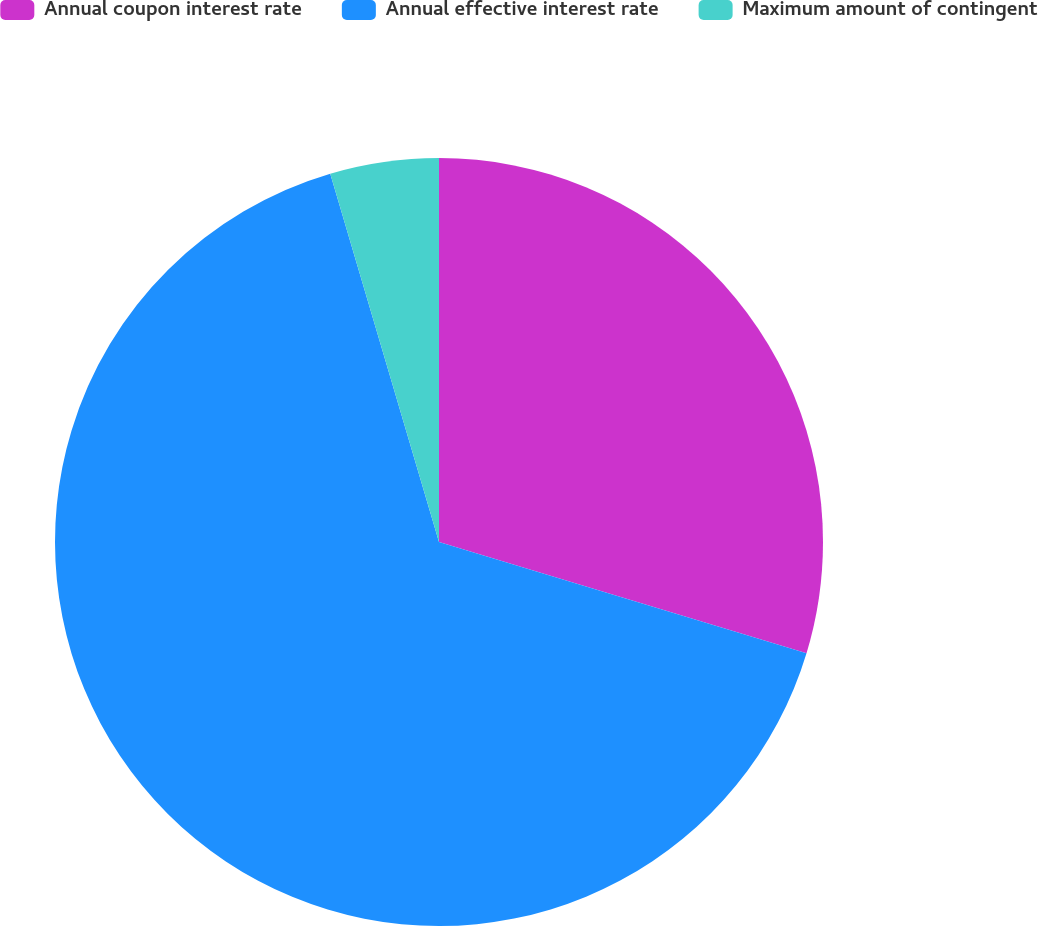<chart> <loc_0><loc_0><loc_500><loc_500><pie_chart><fcel>Annual coupon interest rate<fcel>Annual effective interest rate<fcel>Maximum amount of contingent<nl><fcel>29.68%<fcel>65.75%<fcel>4.57%<nl></chart> 